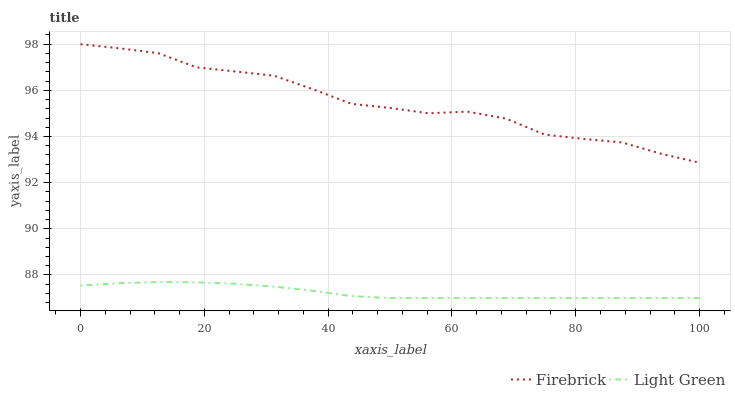Does Light Green have the minimum area under the curve?
Answer yes or no. Yes. Does Firebrick have the maximum area under the curve?
Answer yes or no. Yes. Does Light Green have the maximum area under the curve?
Answer yes or no. No. Is Light Green the smoothest?
Answer yes or no. Yes. Is Firebrick the roughest?
Answer yes or no. Yes. Is Light Green the roughest?
Answer yes or no. No. Does Light Green have the lowest value?
Answer yes or no. Yes. Does Firebrick have the highest value?
Answer yes or no. Yes. Does Light Green have the highest value?
Answer yes or no. No. Is Light Green less than Firebrick?
Answer yes or no. Yes. Is Firebrick greater than Light Green?
Answer yes or no. Yes. Does Light Green intersect Firebrick?
Answer yes or no. No. 